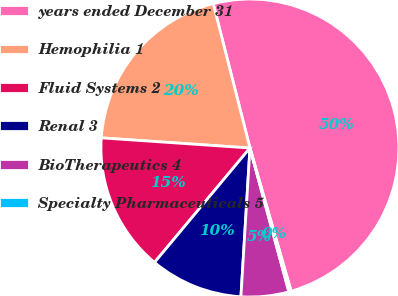<chart> <loc_0><loc_0><loc_500><loc_500><pie_chart><fcel>years ended December 31<fcel>Hemophilia 1<fcel>Fluid Systems 2<fcel>Renal 3<fcel>BioTherapeutics 4<fcel>Specialty Pharmaceuticals 5<nl><fcel>49.51%<fcel>19.95%<fcel>15.02%<fcel>10.1%<fcel>5.17%<fcel>0.25%<nl></chart> 